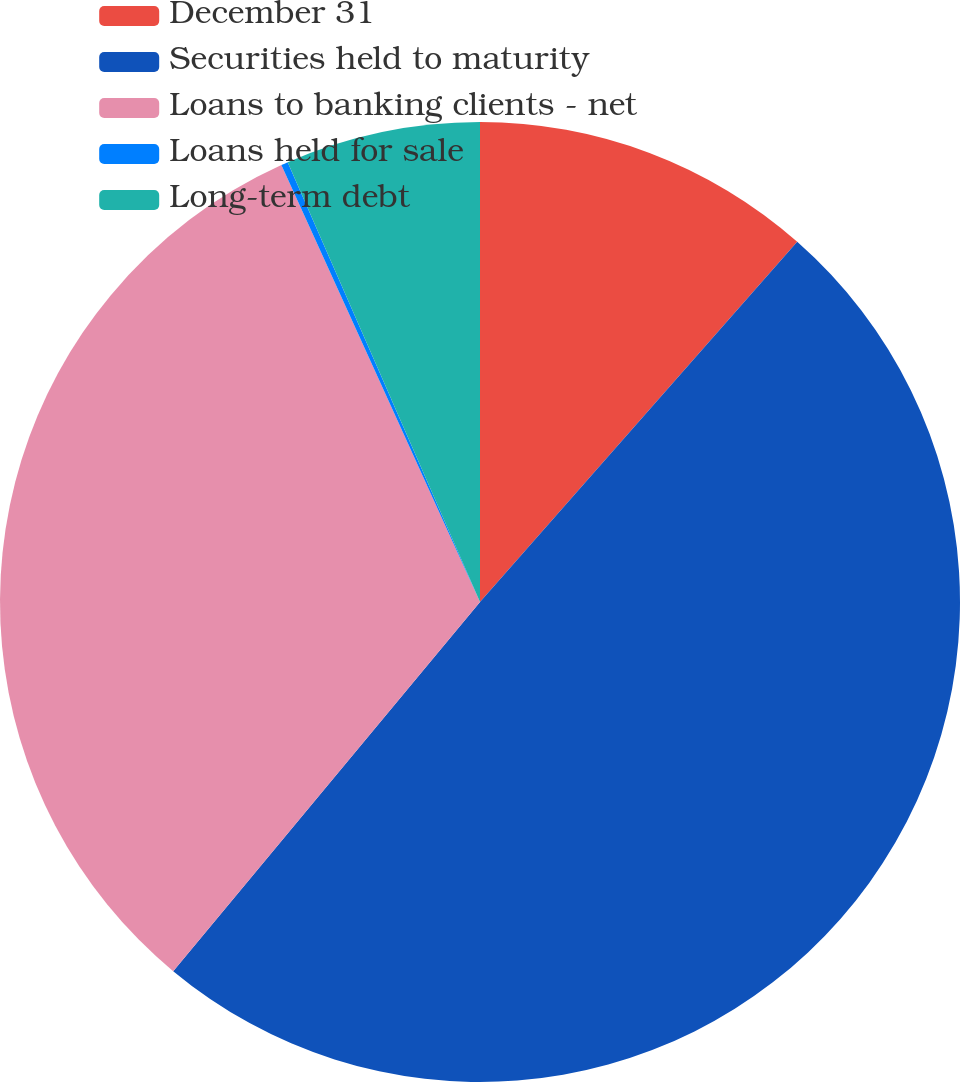Convert chart to OTSL. <chart><loc_0><loc_0><loc_500><loc_500><pie_chart><fcel>December 31<fcel>Securities held to maturity<fcel>Loans to banking clients - net<fcel>Loans held for sale<fcel>Long-term debt<nl><fcel>11.49%<fcel>49.54%<fcel>32.17%<fcel>0.23%<fcel>6.56%<nl></chart> 